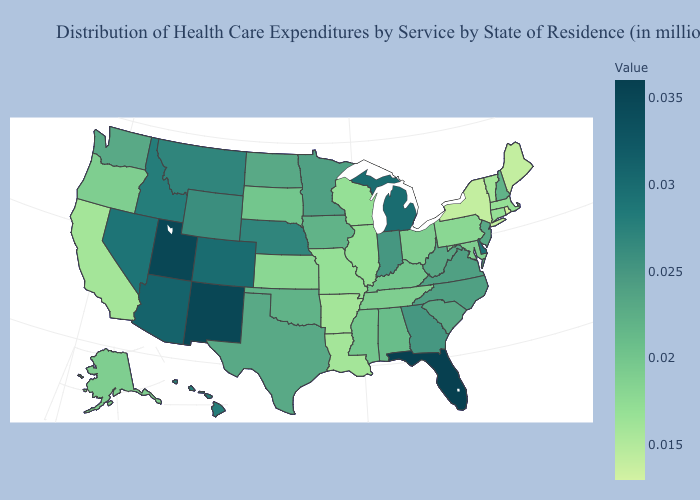Which states hav the highest value in the West?
Write a very short answer. New Mexico, Utah. Among the states that border Missouri , which have the lowest value?
Answer briefly. Arkansas. Is the legend a continuous bar?
Answer briefly. Yes. Does California have the lowest value in the West?
Give a very brief answer. Yes. Among the states that border Florida , does Alabama have the highest value?
Concise answer only. No. Does Nevada have the highest value in the West?
Give a very brief answer. No. 